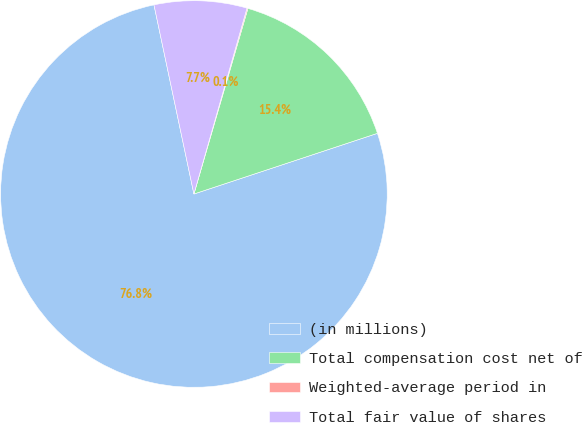<chart> <loc_0><loc_0><loc_500><loc_500><pie_chart><fcel>(in millions)<fcel>Total compensation cost net of<fcel>Weighted-average period in<fcel>Total fair value of shares<nl><fcel>76.77%<fcel>15.41%<fcel>0.08%<fcel>7.74%<nl></chart> 